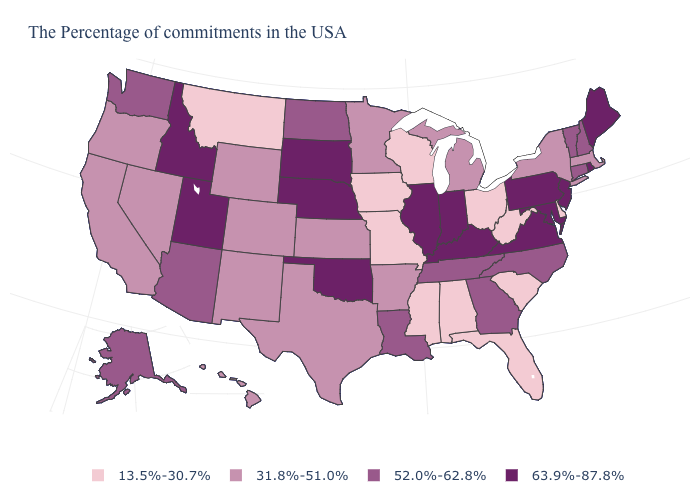Does Idaho have the highest value in the USA?
Short answer required. Yes. How many symbols are there in the legend?
Write a very short answer. 4. Does the first symbol in the legend represent the smallest category?
Keep it brief. Yes. Name the states that have a value in the range 63.9%-87.8%?
Write a very short answer. Maine, Rhode Island, New Jersey, Maryland, Pennsylvania, Virginia, Kentucky, Indiana, Illinois, Nebraska, Oklahoma, South Dakota, Utah, Idaho. Name the states that have a value in the range 63.9%-87.8%?
Answer briefly. Maine, Rhode Island, New Jersey, Maryland, Pennsylvania, Virginia, Kentucky, Indiana, Illinois, Nebraska, Oklahoma, South Dakota, Utah, Idaho. Among the states that border Ohio , which have the lowest value?
Short answer required. West Virginia. Which states have the highest value in the USA?
Write a very short answer. Maine, Rhode Island, New Jersey, Maryland, Pennsylvania, Virginia, Kentucky, Indiana, Illinois, Nebraska, Oklahoma, South Dakota, Utah, Idaho. What is the lowest value in the West?
Keep it brief. 13.5%-30.7%. How many symbols are there in the legend?
Answer briefly. 4. Among the states that border Connecticut , does New York have the lowest value?
Quick response, please. Yes. Among the states that border North Dakota , which have the lowest value?
Give a very brief answer. Montana. What is the value of Maryland?
Keep it brief. 63.9%-87.8%. Name the states that have a value in the range 63.9%-87.8%?
Quick response, please. Maine, Rhode Island, New Jersey, Maryland, Pennsylvania, Virginia, Kentucky, Indiana, Illinois, Nebraska, Oklahoma, South Dakota, Utah, Idaho. Name the states that have a value in the range 13.5%-30.7%?
Write a very short answer. Delaware, South Carolina, West Virginia, Ohio, Florida, Alabama, Wisconsin, Mississippi, Missouri, Iowa, Montana. Among the states that border Maryland , does Virginia have the highest value?
Keep it brief. Yes. 